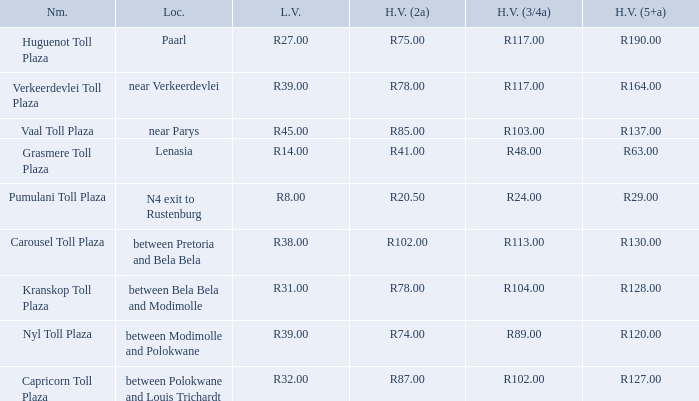What is the cost for light vehicles to pass through the toll plaza between bela bela and modimolle? R31.00. 